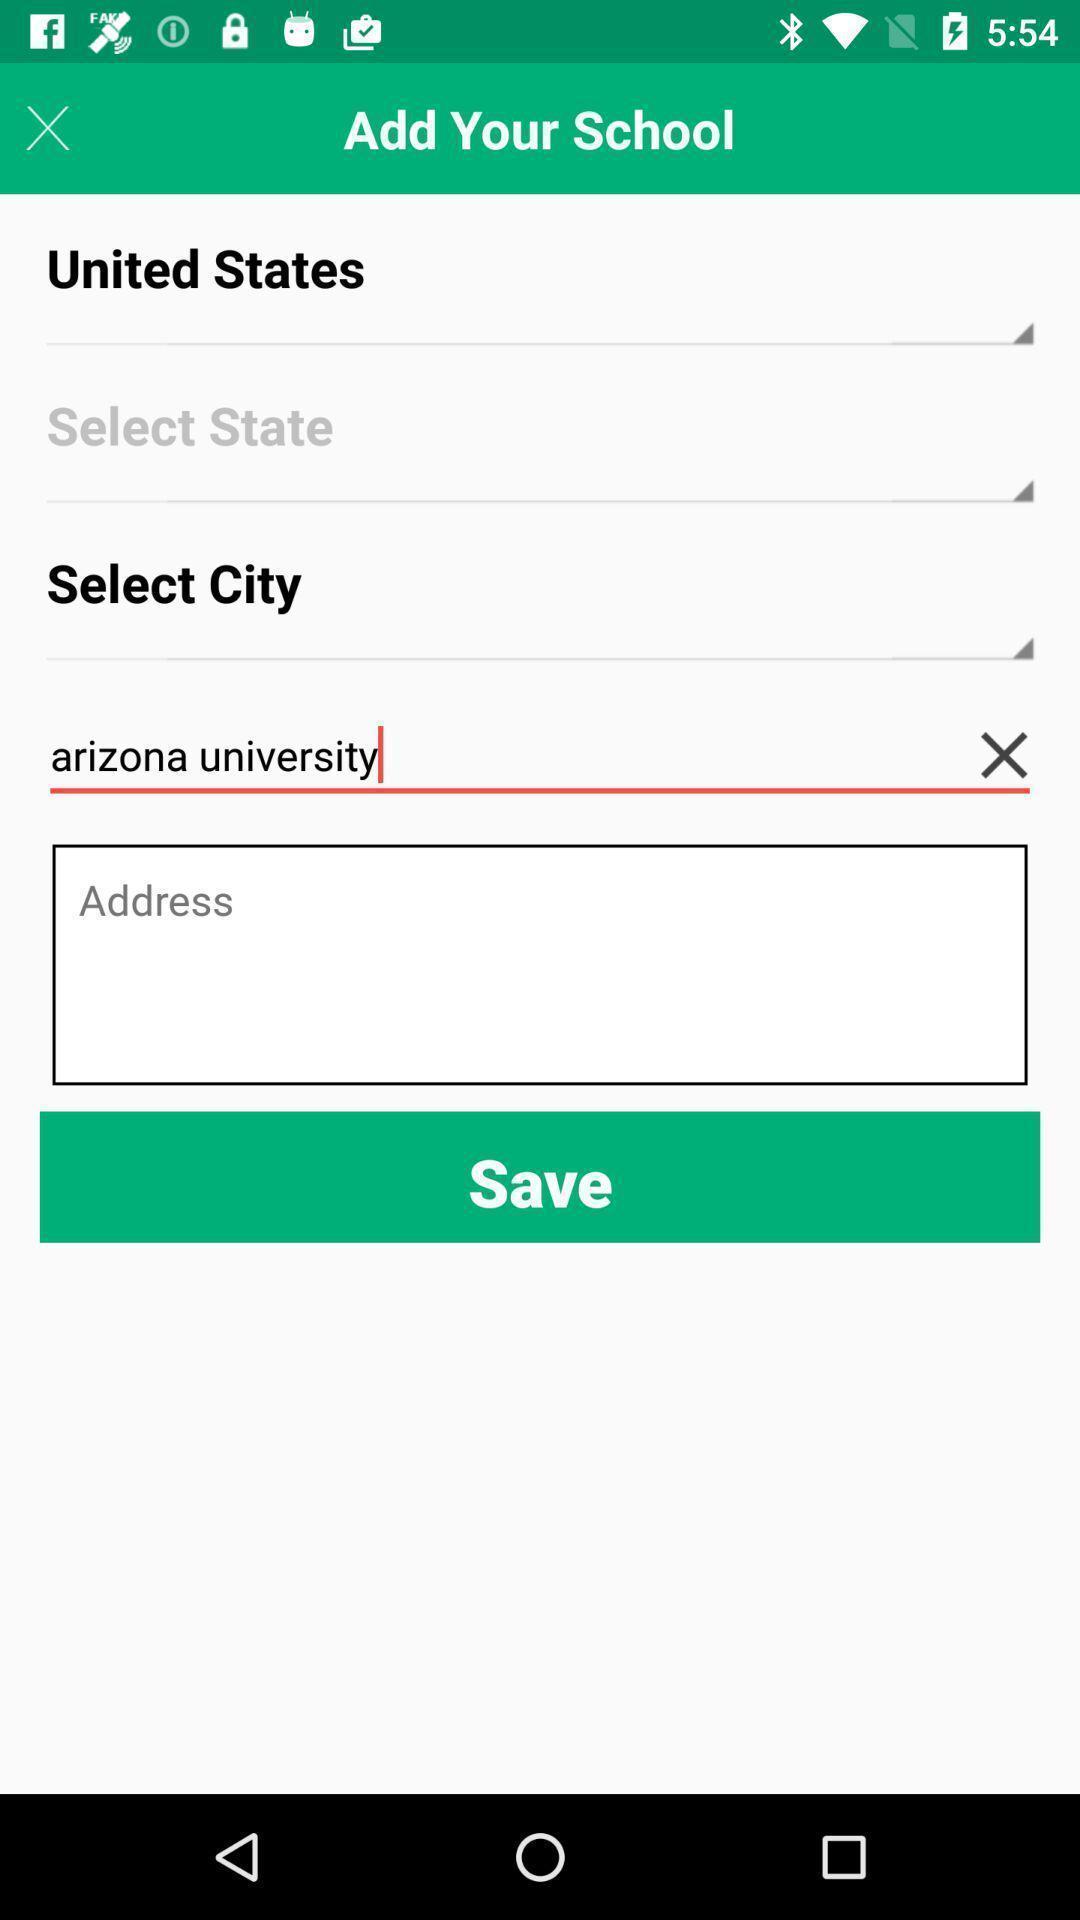Summarize the information in this screenshot. School details to enter in the application. 